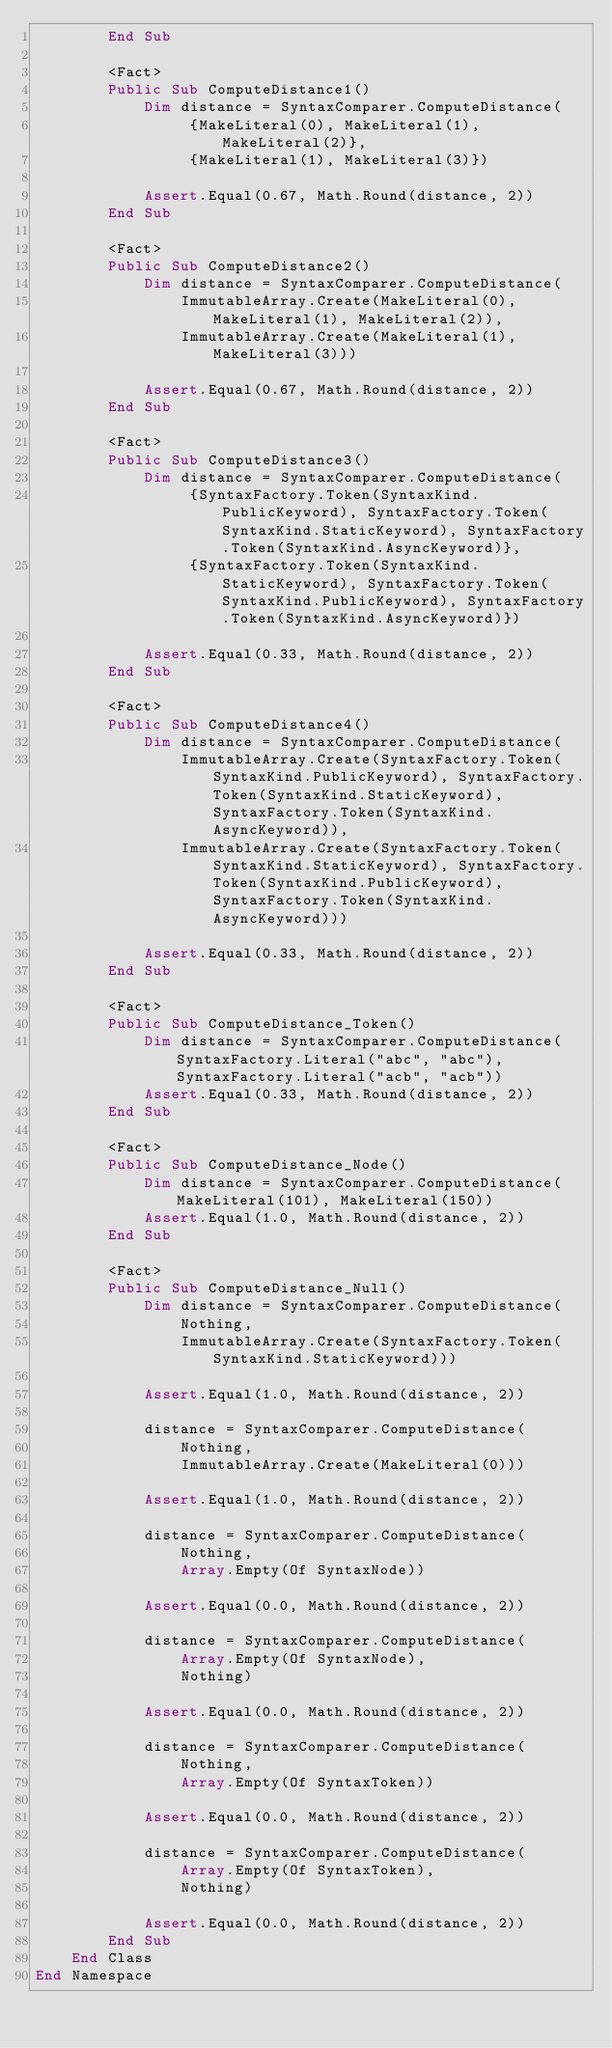Convert code to text. <code><loc_0><loc_0><loc_500><loc_500><_VisualBasic_>        End Sub

        <Fact>
        Public Sub ComputeDistance1()
            Dim distance = SyntaxComparer.ComputeDistance(
                 {MakeLiteral(0), MakeLiteral(1), MakeLiteral(2)},
                 {MakeLiteral(1), MakeLiteral(3)})

            Assert.Equal(0.67, Math.Round(distance, 2))
        End Sub

        <Fact>
        Public Sub ComputeDistance2()
            Dim distance = SyntaxComparer.ComputeDistance(
                ImmutableArray.Create(MakeLiteral(0), MakeLiteral(1), MakeLiteral(2)),
                ImmutableArray.Create(MakeLiteral(1), MakeLiteral(3)))

            Assert.Equal(0.67, Math.Round(distance, 2))
        End Sub

        <Fact>
        Public Sub ComputeDistance3()
            Dim distance = SyntaxComparer.ComputeDistance(
                 {SyntaxFactory.Token(SyntaxKind.PublicKeyword), SyntaxFactory.Token(SyntaxKind.StaticKeyword), SyntaxFactory.Token(SyntaxKind.AsyncKeyword)},
                 {SyntaxFactory.Token(SyntaxKind.StaticKeyword), SyntaxFactory.Token(SyntaxKind.PublicKeyword), SyntaxFactory.Token(SyntaxKind.AsyncKeyword)})

            Assert.Equal(0.33, Math.Round(distance, 2))
        End Sub

        <Fact>
        Public Sub ComputeDistance4()
            Dim distance = SyntaxComparer.ComputeDistance(
                ImmutableArray.Create(SyntaxFactory.Token(SyntaxKind.PublicKeyword), SyntaxFactory.Token(SyntaxKind.StaticKeyword), SyntaxFactory.Token(SyntaxKind.AsyncKeyword)),
                ImmutableArray.Create(SyntaxFactory.Token(SyntaxKind.StaticKeyword), SyntaxFactory.Token(SyntaxKind.PublicKeyword), SyntaxFactory.Token(SyntaxKind.AsyncKeyword)))

            Assert.Equal(0.33, Math.Round(distance, 2))
        End Sub

        <Fact>
        Public Sub ComputeDistance_Token()
            Dim distance = SyntaxComparer.ComputeDistance(SyntaxFactory.Literal("abc", "abc"), SyntaxFactory.Literal("acb", "acb"))
            Assert.Equal(0.33, Math.Round(distance, 2))
        End Sub

        <Fact>
        Public Sub ComputeDistance_Node()
            Dim distance = SyntaxComparer.ComputeDistance(MakeLiteral(101), MakeLiteral(150))
            Assert.Equal(1.0, Math.Round(distance, 2))
        End Sub

        <Fact>
        Public Sub ComputeDistance_Null()
            Dim distance = SyntaxComparer.ComputeDistance(
                Nothing,
                ImmutableArray.Create(SyntaxFactory.Token(SyntaxKind.StaticKeyword)))

            Assert.Equal(1.0, Math.Round(distance, 2))

            distance = SyntaxComparer.ComputeDistance(
                Nothing,
                ImmutableArray.Create(MakeLiteral(0)))

            Assert.Equal(1.0, Math.Round(distance, 2))

            distance = SyntaxComparer.ComputeDistance(
                Nothing,
                Array.Empty(Of SyntaxNode))

            Assert.Equal(0.0, Math.Round(distance, 2))

            distance = SyntaxComparer.ComputeDistance(
                Array.Empty(Of SyntaxNode),
                Nothing)

            Assert.Equal(0.0, Math.Round(distance, 2))

            distance = SyntaxComparer.ComputeDistance(
                Nothing,
                Array.Empty(Of SyntaxToken))

            Assert.Equal(0.0, Math.Round(distance, 2))

            distance = SyntaxComparer.ComputeDistance(
                Array.Empty(Of SyntaxToken),
                Nothing)

            Assert.Equal(0.0, Math.Round(distance, 2))
        End Sub
    End Class
End Namespace
</code> 